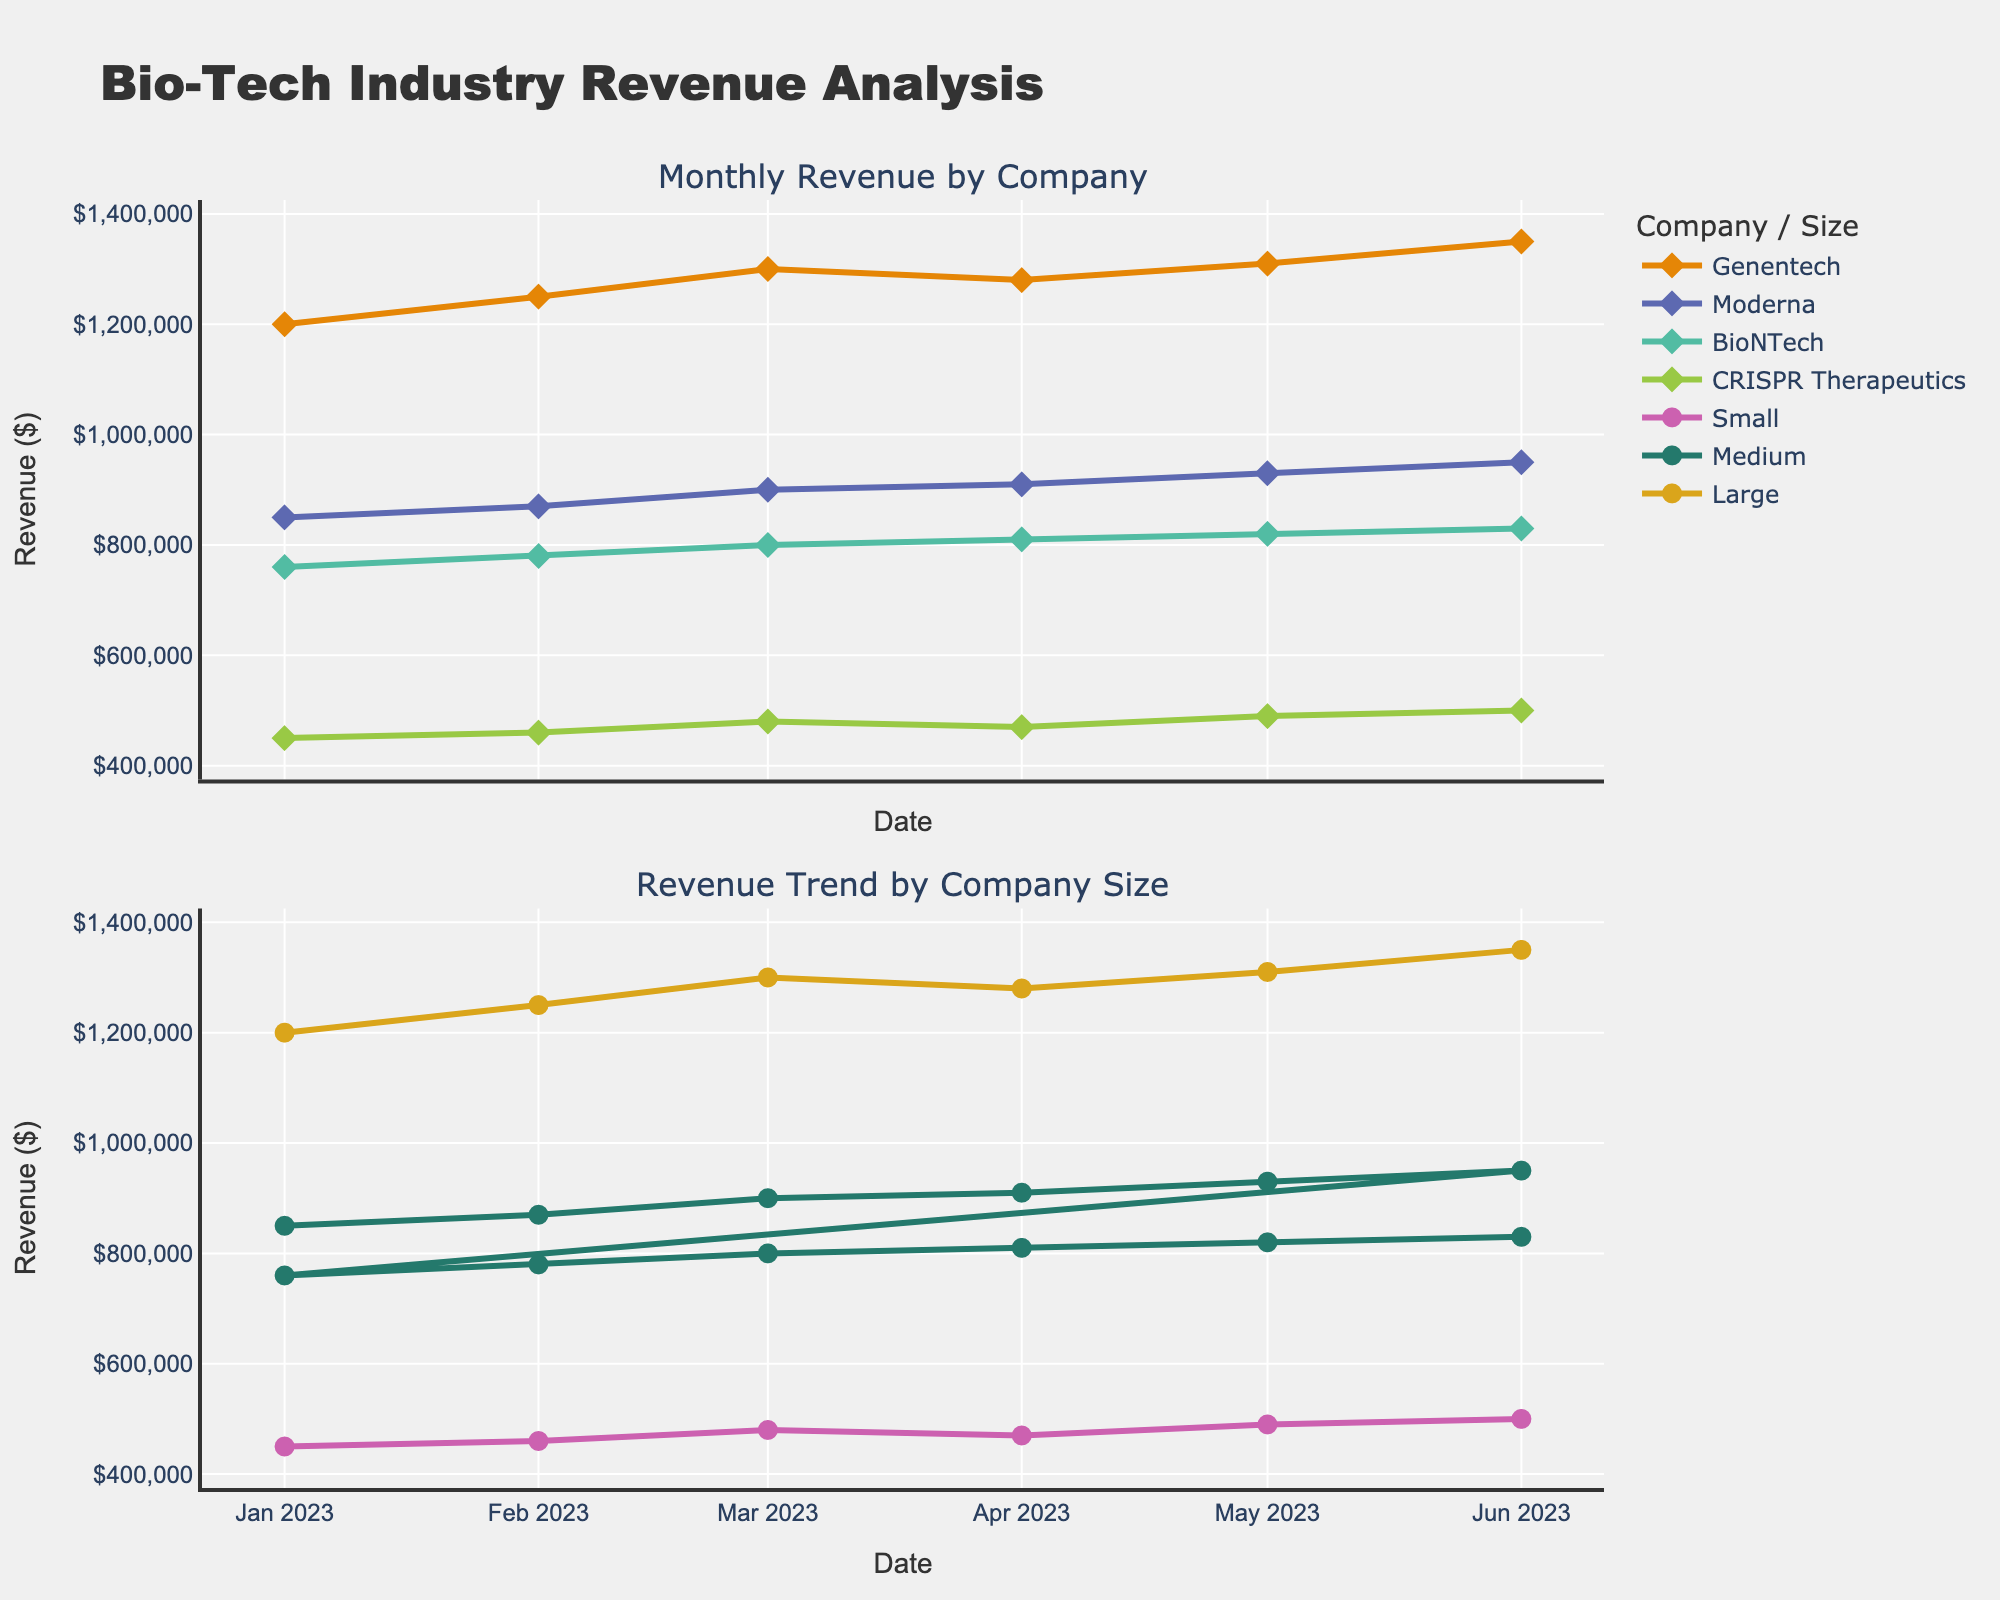1. What is the main title of the figure? The main title of the figure is displayed at the top of the plot. It summarizes the overall content of the plot.
Answer: Bio-Tech Industry Revenue Analysis 2. Which company has the highest revenue in June 2023? By examining the first subplot that shows the monthly revenue for each company, we can observe the markers and lines for June 2023. Genentech's revenue is the highest in June 2023.
Answer: Genentech 3. How did the revenue of CRISPR Therapeutics change from January to June 2023? Check the scatter points and the line trend for CRISPR Therapeutics in the top subplot. The line starts at 450,000 in January and ends at 500,000 in June. This shows an increasing trend.
Answer: It increased 4. What is the overall trend in revenue for medium-sized companies from January to June 2023? In the second subplot, observe the data points and lines for the medium-sized category from January to June. Both Moderna and BioNTech, which are medium-sized companies, show increasing trends over time.
Answer: Increasing 5. Compare the revenue trend between small-sized and large-sized companies over the months. Look at the patterns in the bottom subplot for small-sized (CRISPR Therapeutics) and large-sized (Genentech) companies. The small-sized company shows a gradual increase, while the large-sized company shows a steeper increase, indicating the large-sized company's revenue grew more significantly.
Answer: Large-sized companies saw a steeper increase 6. Which month shows a slight decrease in revenue for Genentech? In the top subplot, observe the points and line for Genentech. The revenue drops slightly from March 2023 to April 2023.
Answer: April 2023 7. Calculate the difference in revenue between Genentech and Moderna in February 2023. From the first subplot, find the revenue values for Genentech (1,250,000) and Moderna (870,000) in February 2023. Subtract Moderna's revenue from Genentech's. 1,250,000 - 870,000 = 380,000.
Answer: $380,000 8. How does the legend help in understanding the plot? The legend categorizes the data by company and company size with distinct colors and symbols, aiding in quick identification of trends and comparisons within the figure.
Answer: Helps categorize and differentiate data 9. Identify one trend observable for BioNTech from January to June 2023. In the first subplot, observe the plot for BioNTech. The revenue showed a consistent increase over the months within the plotted range.
Answer: Consistent increase 10. What is the pattern of the revenue trend for medium-sized companies from April to May 2023? Look at the line connecting April and May data points for medium-sized companies in the bottom subplot. The lines for both Moderna and BioNTech show a situation where revenue is increasing from April to May.
Answer: Increasing 